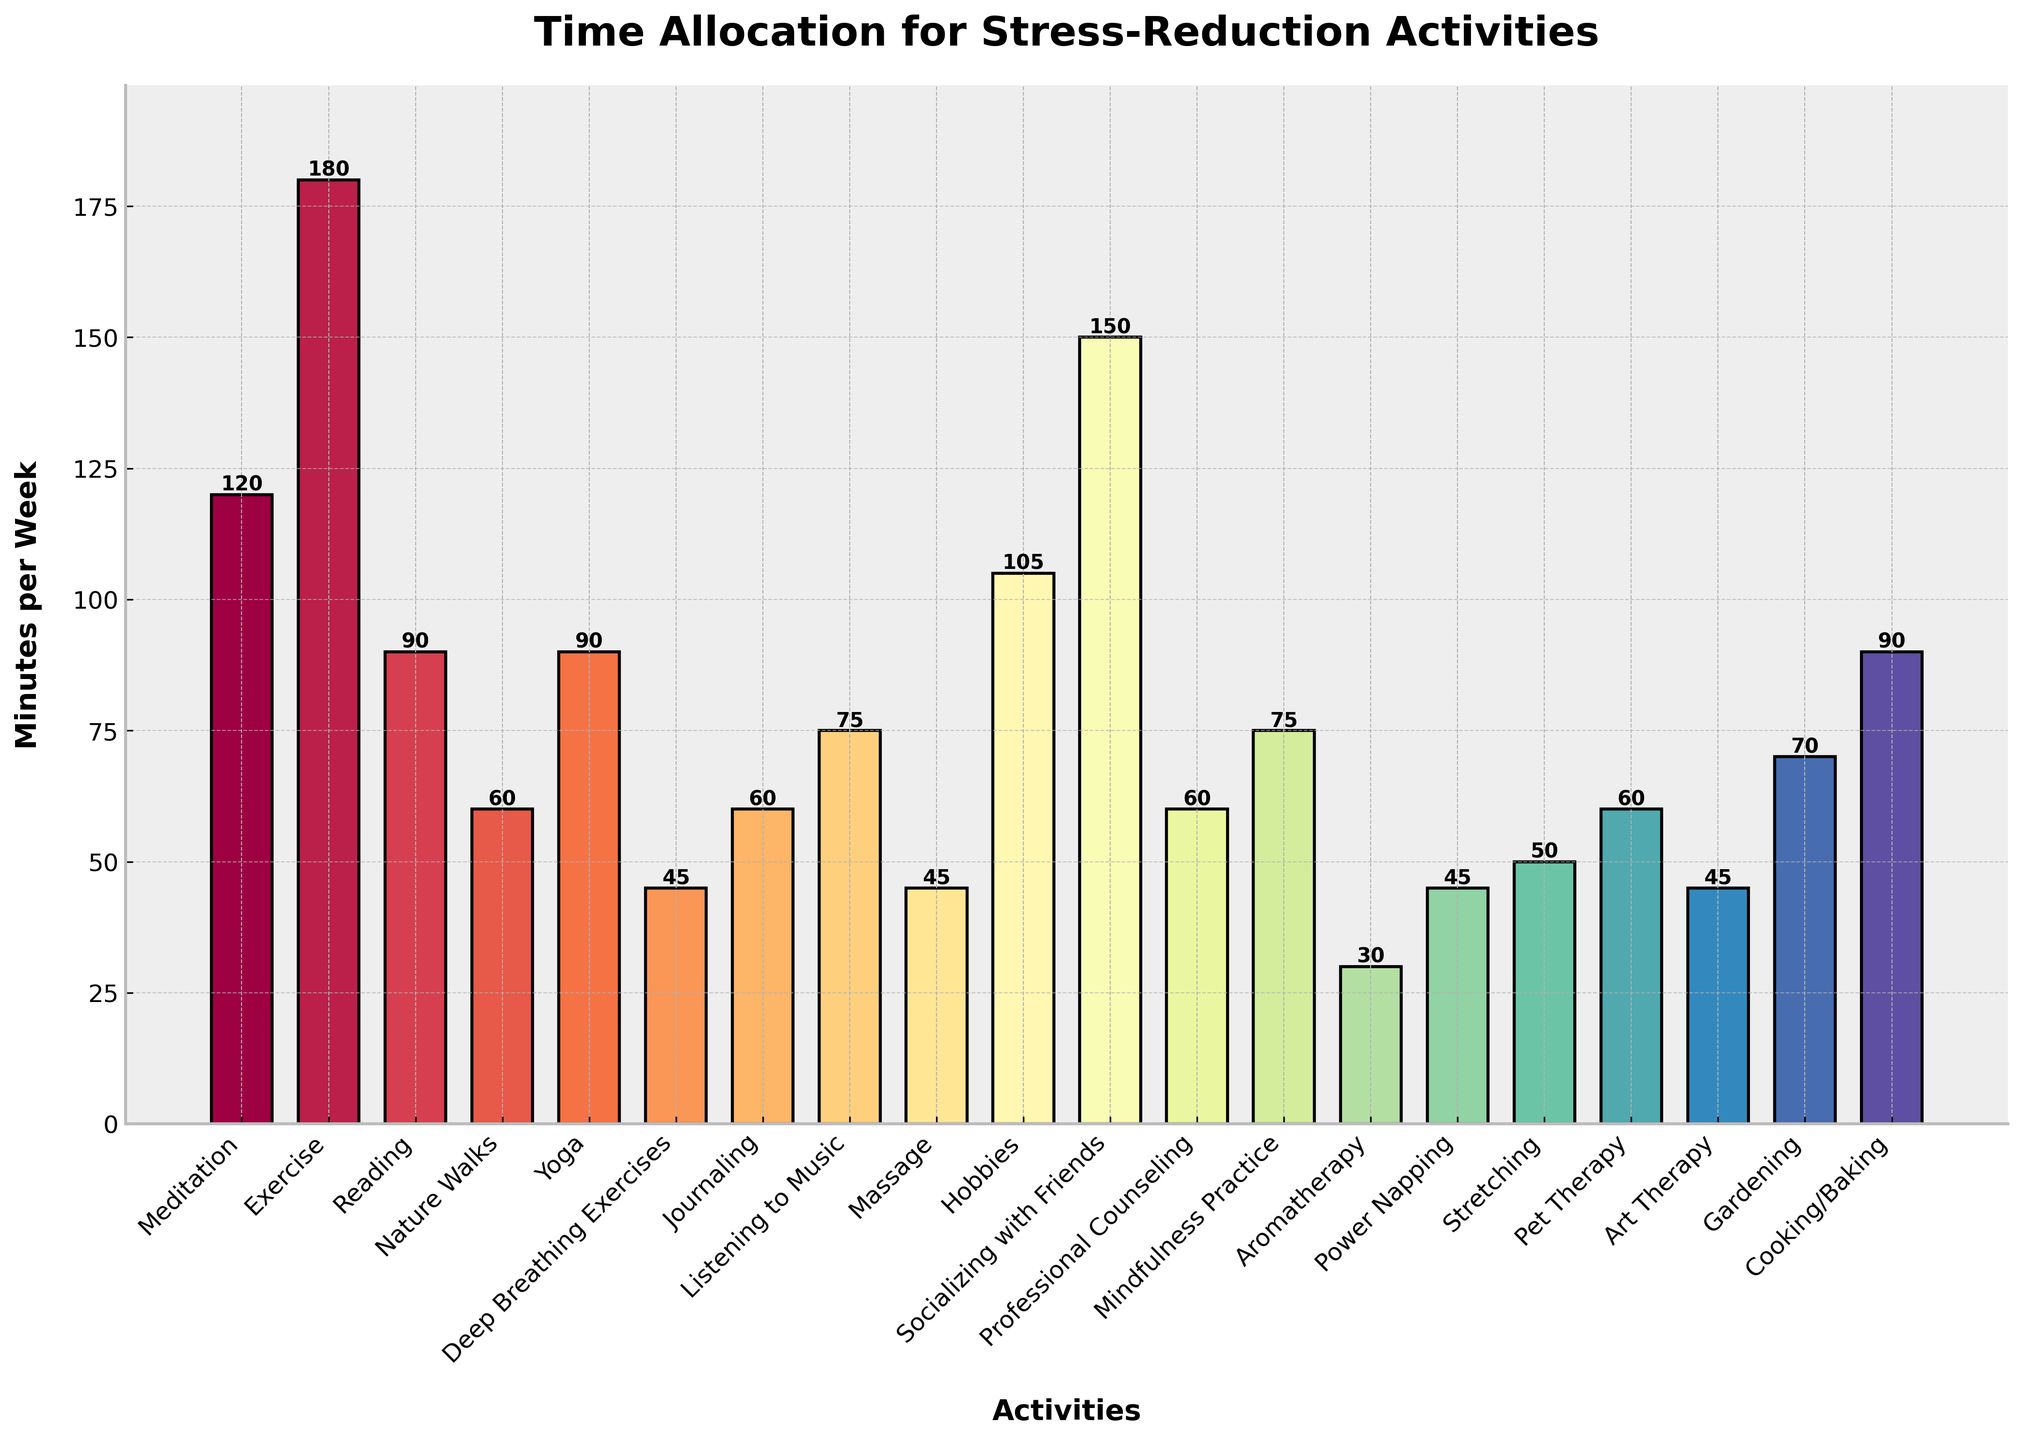Which activity is allocated the most time per week? Look at the bar with the highest value. Exercise has the longest bar, indicating it is allocated the most time per week.
Answer: Exercise Which activities have the same amount of time allocated weekly? Identify bars of the same height. Meditation, Yoga, and Cooking/Baking each have bars indicating 90 minutes per week.
Answer: Meditation, Yoga, Cooking/Baking Which activity has the shortest time allocated, and how much time is it? Look at the bar with the shortest height. Aromatherapy has the shortest bar, indicating 30 minutes per week.
Answer: Aromatherapy, 30 minutes How much more time per week is spent on Meditation compared to Journaling? Find the height for Meditation and Journaling, then subtract. Meditation is 120 minutes and Journaling is 60 minutes, so 120 - 60 = 60 minutes more.
Answer: 60 minutes more What is the combined time spent on activities involving pets and art per week? Sum the values for Pet Therapy and Art Therapy. Pet Therapy is 60 minutes and Art Therapy is 45 minutes, so 60 + 45 = 105 minutes.
Answer: 105 minutes Which activity has the same weekly time allocation as deep breathing exercises? Find the bars with the same height as Deep Breathing Exercises. Both Deep Breathing Exercises and Massage have bars indicating 45 minutes per week.
Answer: Massage How much time in total is allocated to the top three activities? Sum the heights of the top three tallest bars. Exercise (180), Socializing with Friends (150), Meditation (120). So, 180 + 150 + 120 = 450 minutes.
Answer: 450 minutes Which activity has a taller bar: Reading or Listening to Music? Compare the heights of the bars for Reading and Listening to Music. Reading has a 90-minute bar which is taller than Listening to Music's 75-minute bar.
Answer: Reading What is the average weekly time allocation for hobbies-related activities (Hobbies and Gardening)? Sum the values and divide by the number of activities. Hobbies (105) and Gardening (70), so (105 + 70) / 2 = 87.5 minutes.
Answer: 87.5 minutes Which color bars represent activities with less than 50 minutes per week? Identify bars with heights below 50 minutes and note their colors. Deep Breathing Exercises, Massage, Power Napping, Art Therapy, and Aromatherapy have bars of varying colors corresponding to less than 50 minutes.
Answer: Various colors 